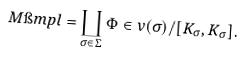<formula> <loc_0><loc_0><loc_500><loc_500>M \i m p l = \coprod _ { \sigma \in \Sigma } \Phi \in v ( \sigma ) / [ K _ { \sigma } , K _ { \sigma } ] .</formula> 